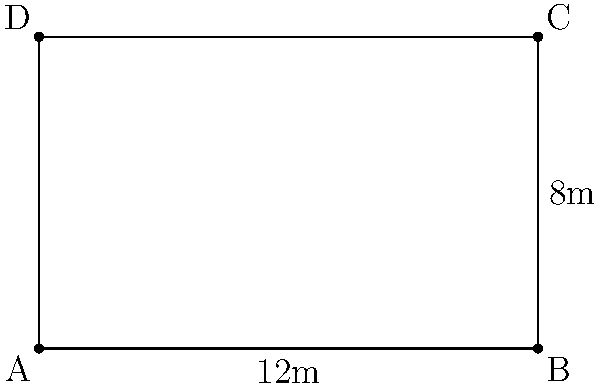In a Buddhist temple, a rectangular prayer hall is being renovated. The hall measures 12 meters in length and 8 meters in width. What is the total area of the prayer hall floor that needs to be covered with new meditation mats? To find the area of the rectangular prayer hall, we need to multiply its length by its width.

Given:
- Length of the prayer hall = 12 meters
- Width of the prayer hall = 8 meters

Step 1: Use the formula for the area of a rectangle:
Area = Length × Width

Step 2: Substitute the given values into the formula:
Area = 12 m × 8 m

Step 3: Perform the multiplication:
Area = 96 m²

Therefore, the total area of the prayer hall floor that needs to be covered with new meditation mats is 96 square meters.
Answer: 96 m² 